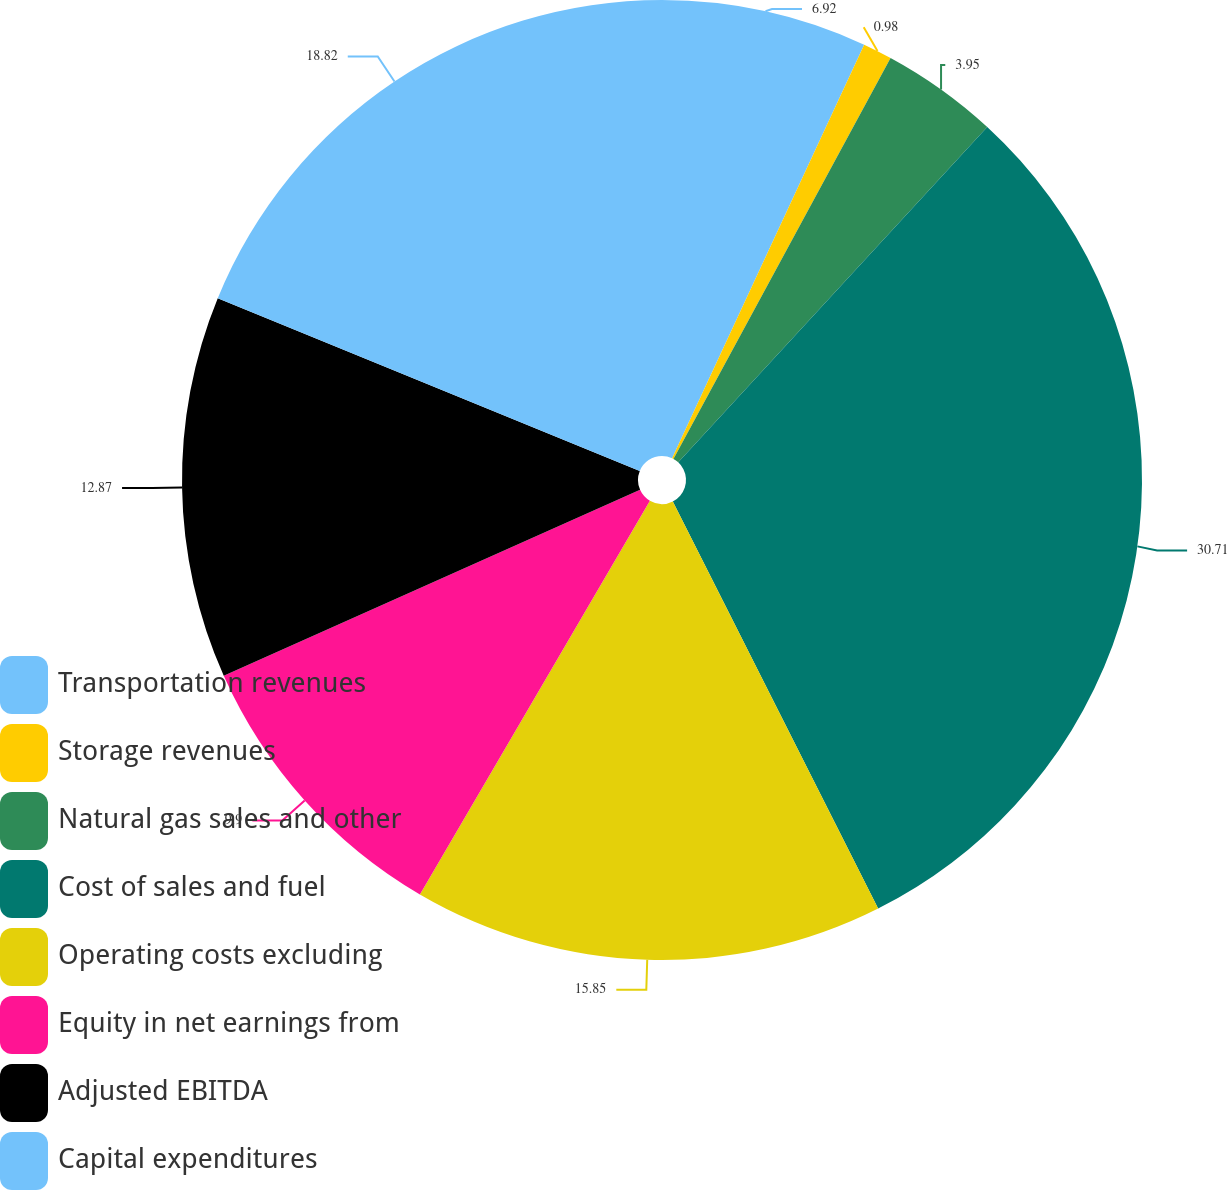<chart> <loc_0><loc_0><loc_500><loc_500><pie_chart><fcel>Transportation revenues<fcel>Storage revenues<fcel>Natural gas sales and other<fcel>Cost of sales and fuel<fcel>Operating costs excluding<fcel>Equity in net earnings from<fcel>Adjusted EBITDA<fcel>Capital expenditures<nl><fcel>6.92%<fcel>0.98%<fcel>3.95%<fcel>30.72%<fcel>15.85%<fcel>9.9%<fcel>12.87%<fcel>18.82%<nl></chart> 